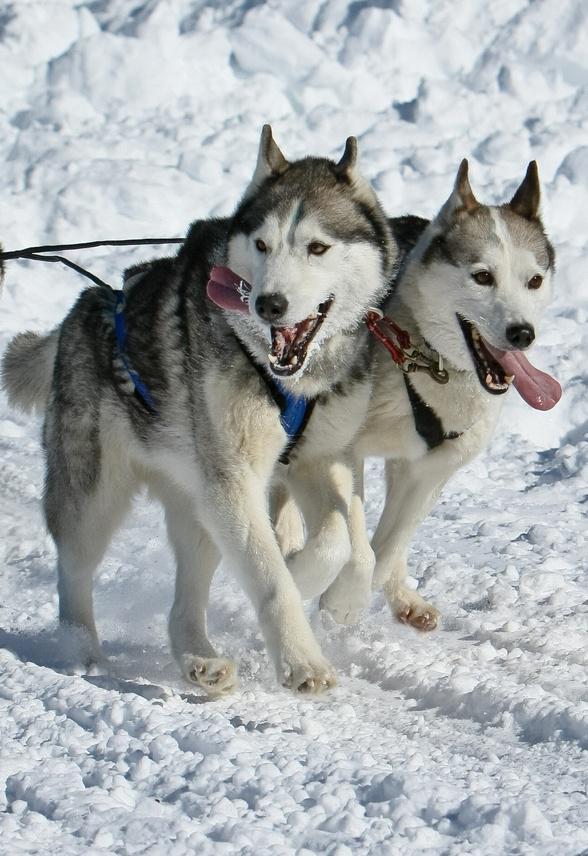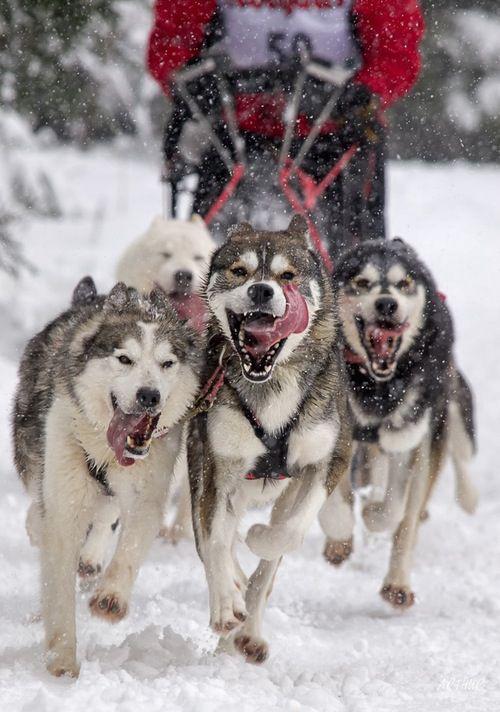The first image is the image on the left, the second image is the image on the right. Considering the images on both sides, is "There are two walking husky harness together with the one on the right sticking out their tongue." valid? Answer yes or no. Yes. 